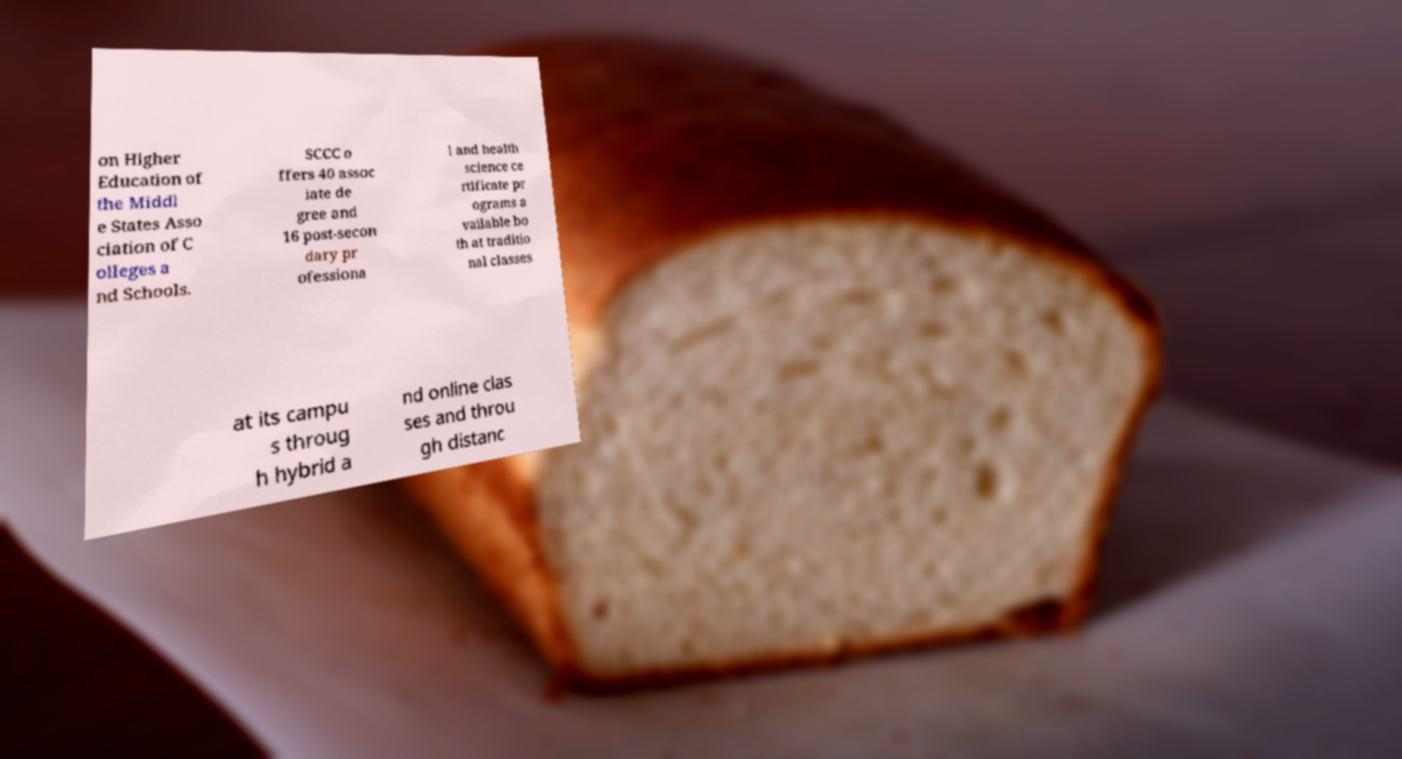Please read and relay the text visible in this image. What does it say? on Higher Education of the Middl e States Asso ciation of C olleges a nd Schools. SCCC o ffers 40 assoc iate de gree and 16 post-secon dary pr ofessiona l and health science ce rtificate pr ograms a vailable bo th at traditio nal classes at its campu s throug h hybrid a nd online clas ses and throu gh distanc 